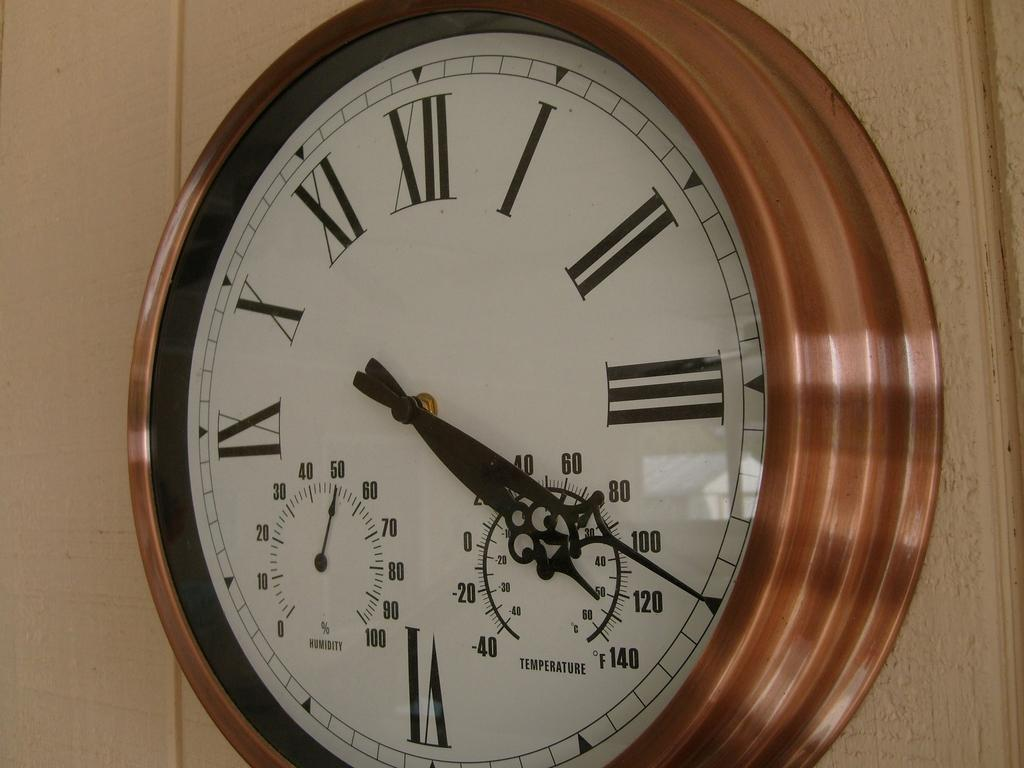<image>
Relay a brief, clear account of the picture shown. According to the clock it is 4:20 and the humidity level is 51%. 